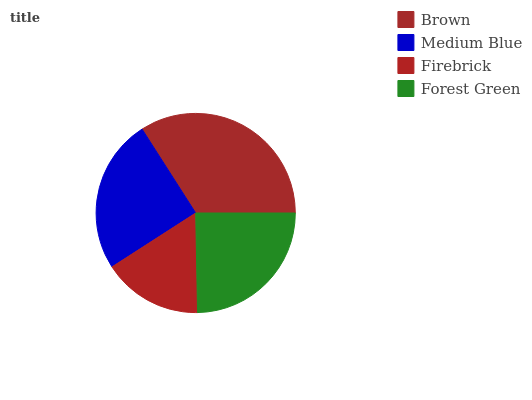Is Firebrick the minimum?
Answer yes or no. Yes. Is Brown the maximum?
Answer yes or no. Yes. Is Medium Blue the minimum?
Answer yes or no. No. Is Medium Blue the maximum?
Answer yes or no. No. Is Brown greater than Medium Blue?
Answer yes or no. Yes. Is Medium Blue less than Brown?
Answer yes or no. Yes. Is Medium Blue greater than Brown?
Answer yes or no. No. Is Brown less than Medium Blue?
Answer yes or no. No. Is Medium Blue the high median?
Answer yes or no. Yes. Is Forest Green the low median?
Answer yes or no. Yes. Is Firebrick the high median?
Answer yes or no. No. Is Firebrick the low median?
Answer yes or no. No. 